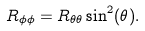Convert formula to latex. <formula><loc_0><loc_0><loc_500><loc_500>R _ { \phi \phi } = R _ { \theta \theta } \sin ^ { 2 } ( \theta ) .</formula> 